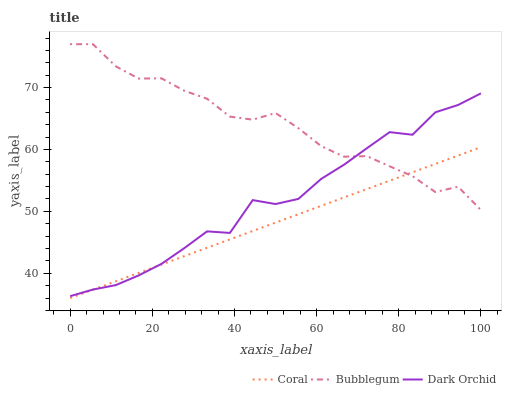Does Coral have the minimum area under the curve?
Answer yes or no. Yes. Does Bubblegum have the maximum area under the curve?
Answer yes or no. Yes. Does Dark Orchid have the minimum area under the curve?
Answer yes or no. No. Does Dark Orchid have the maximum area under the curve?
Answer yes or no. No. Is Coral the smoothest?
Answer yes or no. Yes. Is Bubblegum the roughest?
Answer yes or no. Yes. Is Dark Orchid the smoothest?
Answer yes or no. No. Is Dark Orchid the roughest?
Answer yes or no. No. Does Coral have the lowest value?
Answer yes or no. Yes. Does Dark Orchid have the lowest value?
Answer yes or no. No. Does Bubblegum have the highest value?
Answer yes or no. Yes. Does Dark Orchid have the highest value?
Answer yes or no. No. Does Coral intersect Dark Orchid?
Answer yes or no. Yes. Is Coral less than Dark Orchid?
Answer yes or no. No. Is Coral greater than Dark Orchid?
Answer yes or no. No. 